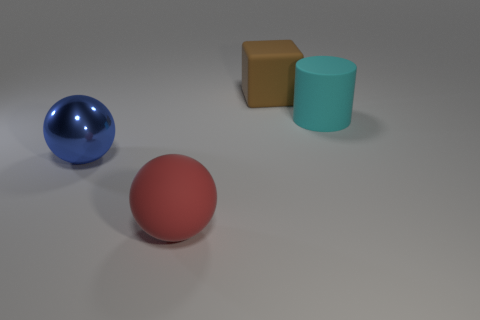How many other objects are there of the same size as the cyan rubber object?
Your answer should be very brief. 3. Does the big thing to the left of the large rubber ball have the same shape as the big matte object in front of the large blue thing?
Make the answer very short. Yes. There is a brown object; are there any brown objects behind it?
Your answer should be very brief. No. What color is the other rubber object that is the same shape as the blue object?
Your answer should be compact. Red. Is there any other thing that has the same shape as the red rubber thing?
Keep it short and to the point. Yes. There is a thing on the left side of the red rubber thing; what is its material?
Your response must be concise. Metal. The other metallic object that is the same shape as the big red object is what size?
Your answer should be compact. Large. What number of red cylinders are the same material as the large red ball?
Your response must be concise. 0. What number of things are things behind the big cyan thing or large rubber cubes behind the blue shiny object?
Provide a short and direct response. 1. Is the number of cyan cylinders to the left of the big shiny ball less than the number of rubber cubes?
Offer a terse response. Yes. 